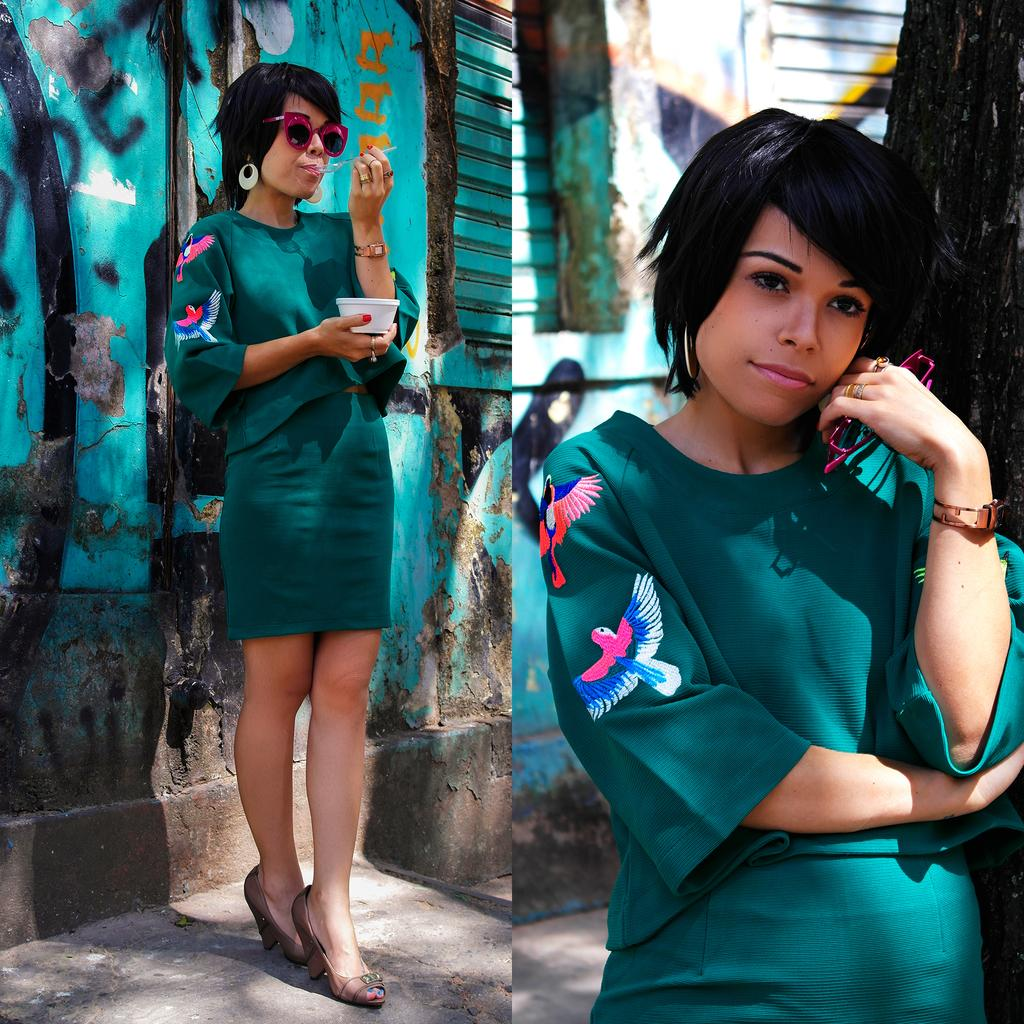What is the person in the image doing? The person is standing in the image. What is the person wearing? The person is wearing a green dress. What is the person holding in the image? The person is holding a bowl. What can be seen in the background of the image? There is a wall in the background of the image. What color is the wall in the image? The wall is green in color. How many girls are playing with the jar in the image? There are no girls or jars present in the image. 